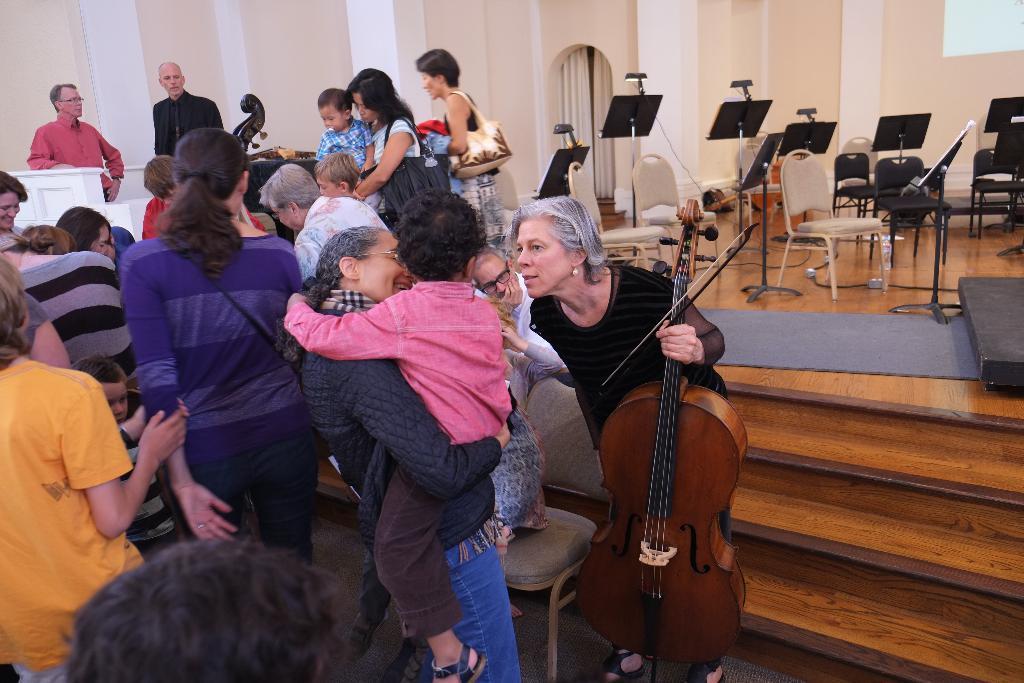In one or two sentences, can you explain what this image depicts? Here we can see people, chairs and boards. This woman is holding a violin.  